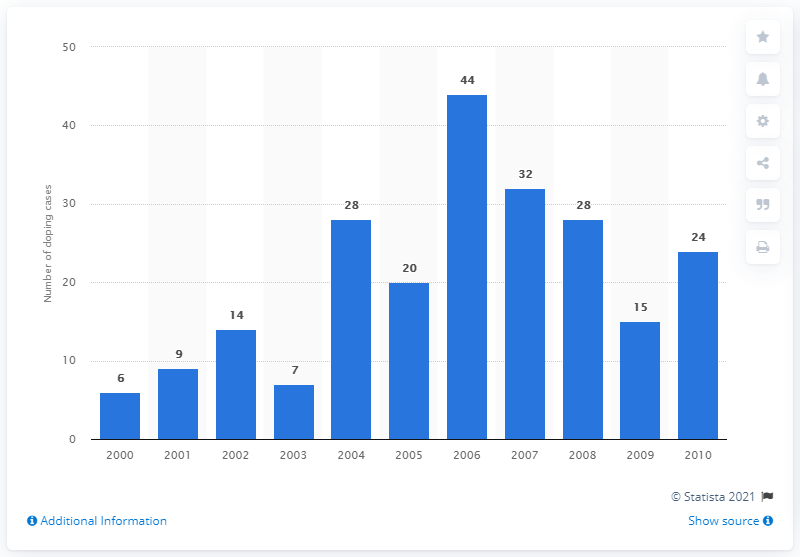Specify some key components in this picture. In 2000, there were six cases of doping. 